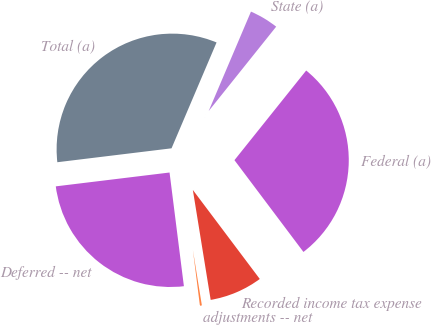<chart> <loc_0><loc_0><loc_500><loc_500><pie_chart><fcel>Federal (a)<fcel>State (a)<fcel>Total (a)<fcel>Deferred -- net<fcel>adjustments -- net<fcel>Recorded income tax expense<nl><fcel>29.0%<fcel>4.34%<fcel>33.33%<fcel>25.07%<fcel>0.56%<fcel>7.7%<nl></chart> 